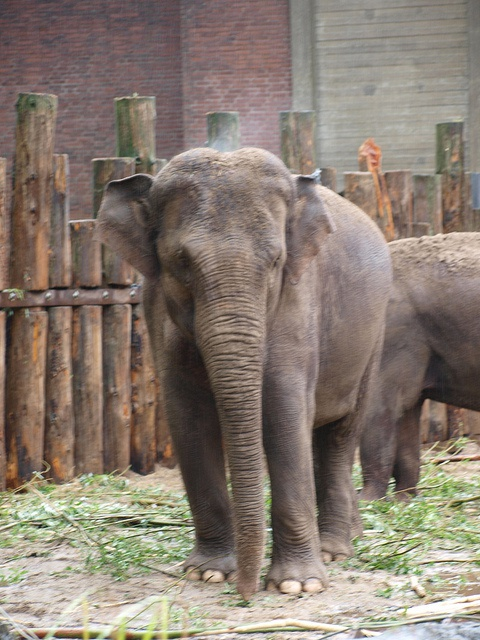Describe the objects in this image and their specific colors. I can see elephant in black, gray, and darkgray tones and elephant in black, gray, and darkgray tones in this image. 